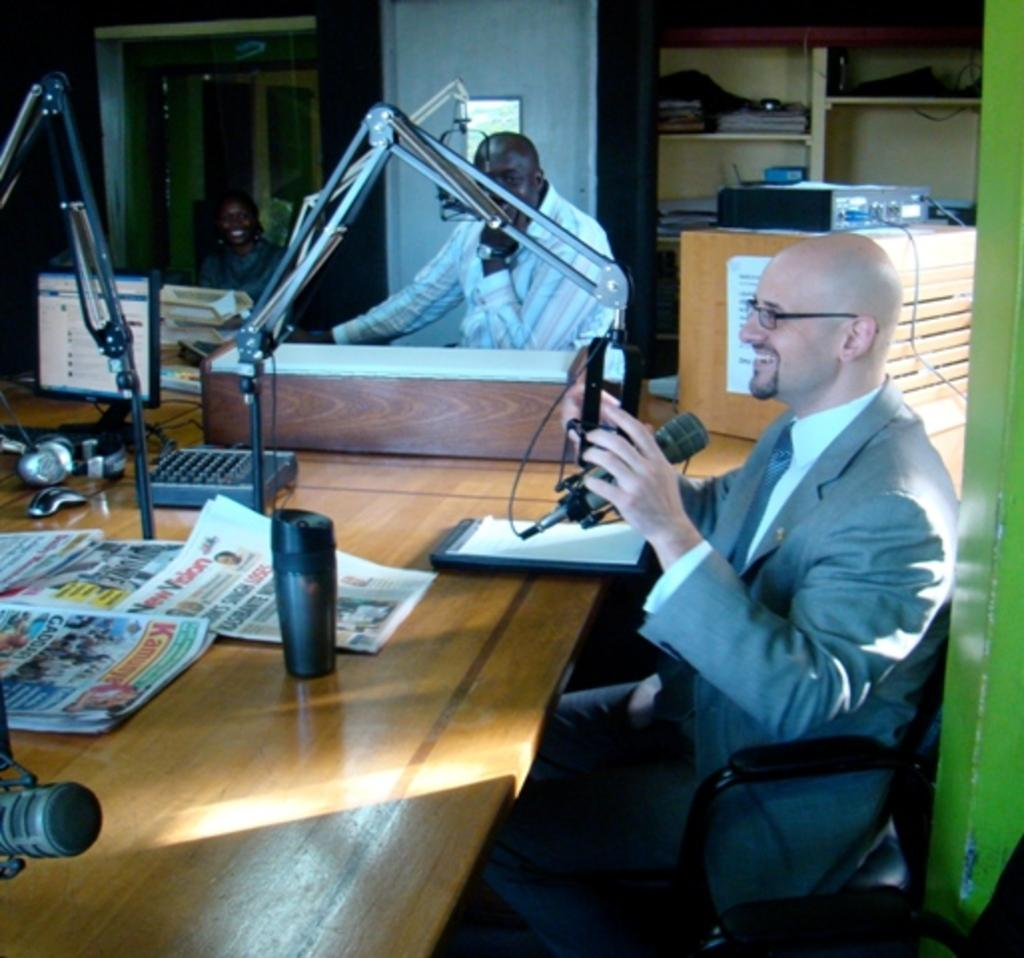What is the person on the right side of the image doing? The person is sitting on the right side of the image and holding a mic. What is in front of the person? There is a table in front of the person. What can be found on the table? The table has a desktop, a headset, and papers on it. Is there anyone else in the image? Yes, there is another person sitting beside the first person. Can you see any jellyfish swimming in the image? No, there are no jellyfish present in the image. What type of bike is the person attempting to ride in the image? There is no bike present in the image, and no one is attempting to ride a bike. 